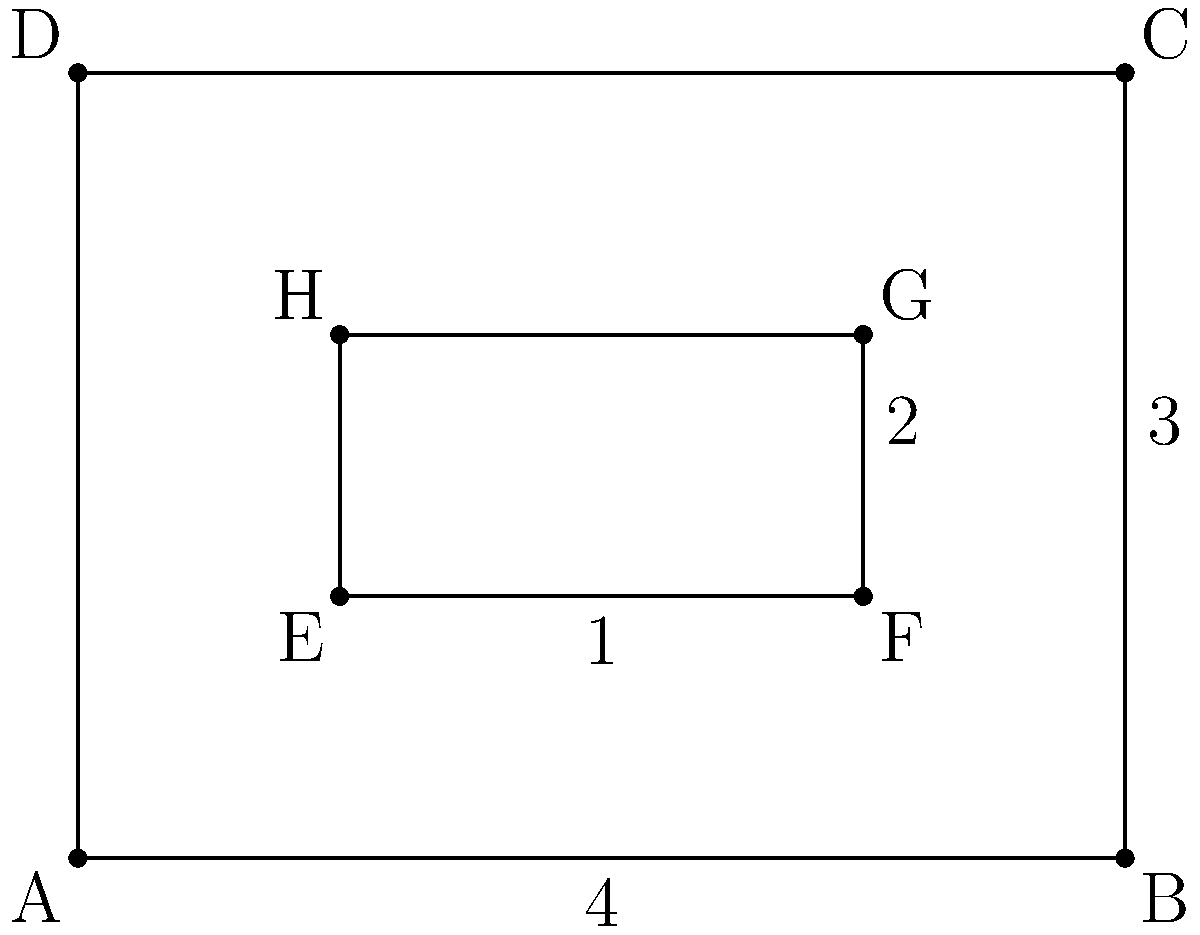Look at this simple floor plan, no fancy terms needed. Which of these is the correct top-down view?

A) A rectangle with a smaller rectangle inside, offset to the bottom-right
B) A square with a smaller square inside, centered
C) A rectangle with a smaller rectangle inside, centered
D) A rectangle with a smaller rectangle inside, offset to the top-left Let's break this down without any highfalutin language:

1. The outer shape is clearly a rectangle, not a square. We can see it's longer in one direction than the other.

2. There's a smaller rectangle inside the big one. This is probably a room or some internal space.

3. This inner rectangle isn't smack in the middle. It's closer to the bottom-right corner of the outer rectangle.

4. If we look at the dimensions, the outer rectangle is 4 units wide and 3 units tall. The inner rectangle is 2 units wide and 1 unit tall.

5. The inner rectangle starts 1 unit from the left and bottom edges of the outer rectangle.

Given these observations, the correct top-down view must be a rectangle with a smaller rectangle inside, offset to the bottom-right. This matches description A in the question.
Answer: A 